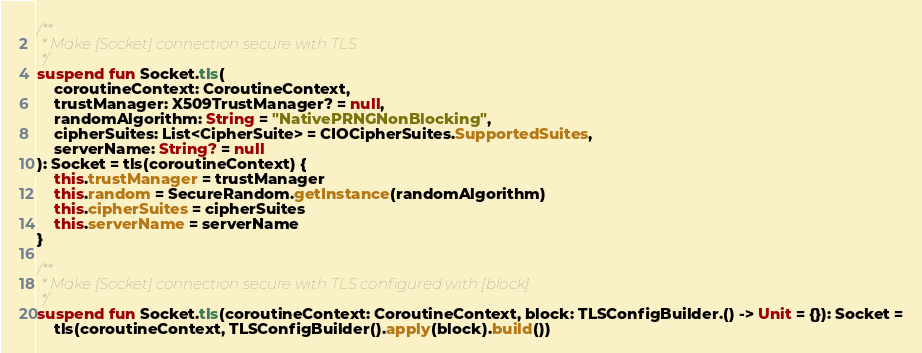Convert code to text. <code><loc_0><loc_0><loc_500><loc_500><_Kotlin_>/**
 * Make [Socket] connection secure with TLS.
 */
suspend fun Socket.tls(
    coroutineContext: CoroutineContext,
    trustManager: X509TrustManager? = null,
    randomAlgorithm: String = "NativePRNGNonBlocking",
    cipherSuites: List<CipherSuite> = CIOCipherSuites.SupportedSuites,
    serverName: String? = null
): Socket = tls(coroutineContext) {
    this.trustManager = trustManager
    this.random = SecureRandom.getInstance(randomAlgorithm)
    this.cipherSuites = cipherSuites
    this.serverName = serverName
}

/**
 * Make [Socket] connection secure with TLS configured with [block].
 */
suspend fun Socket.tls(coroutineContext: CoroutineContext, block: TLSConfigBuilder.() -> Unit = {}): Socket =
    tls(coroutineContext, TLSConfigBuilder().apply(block).build())
</code> 